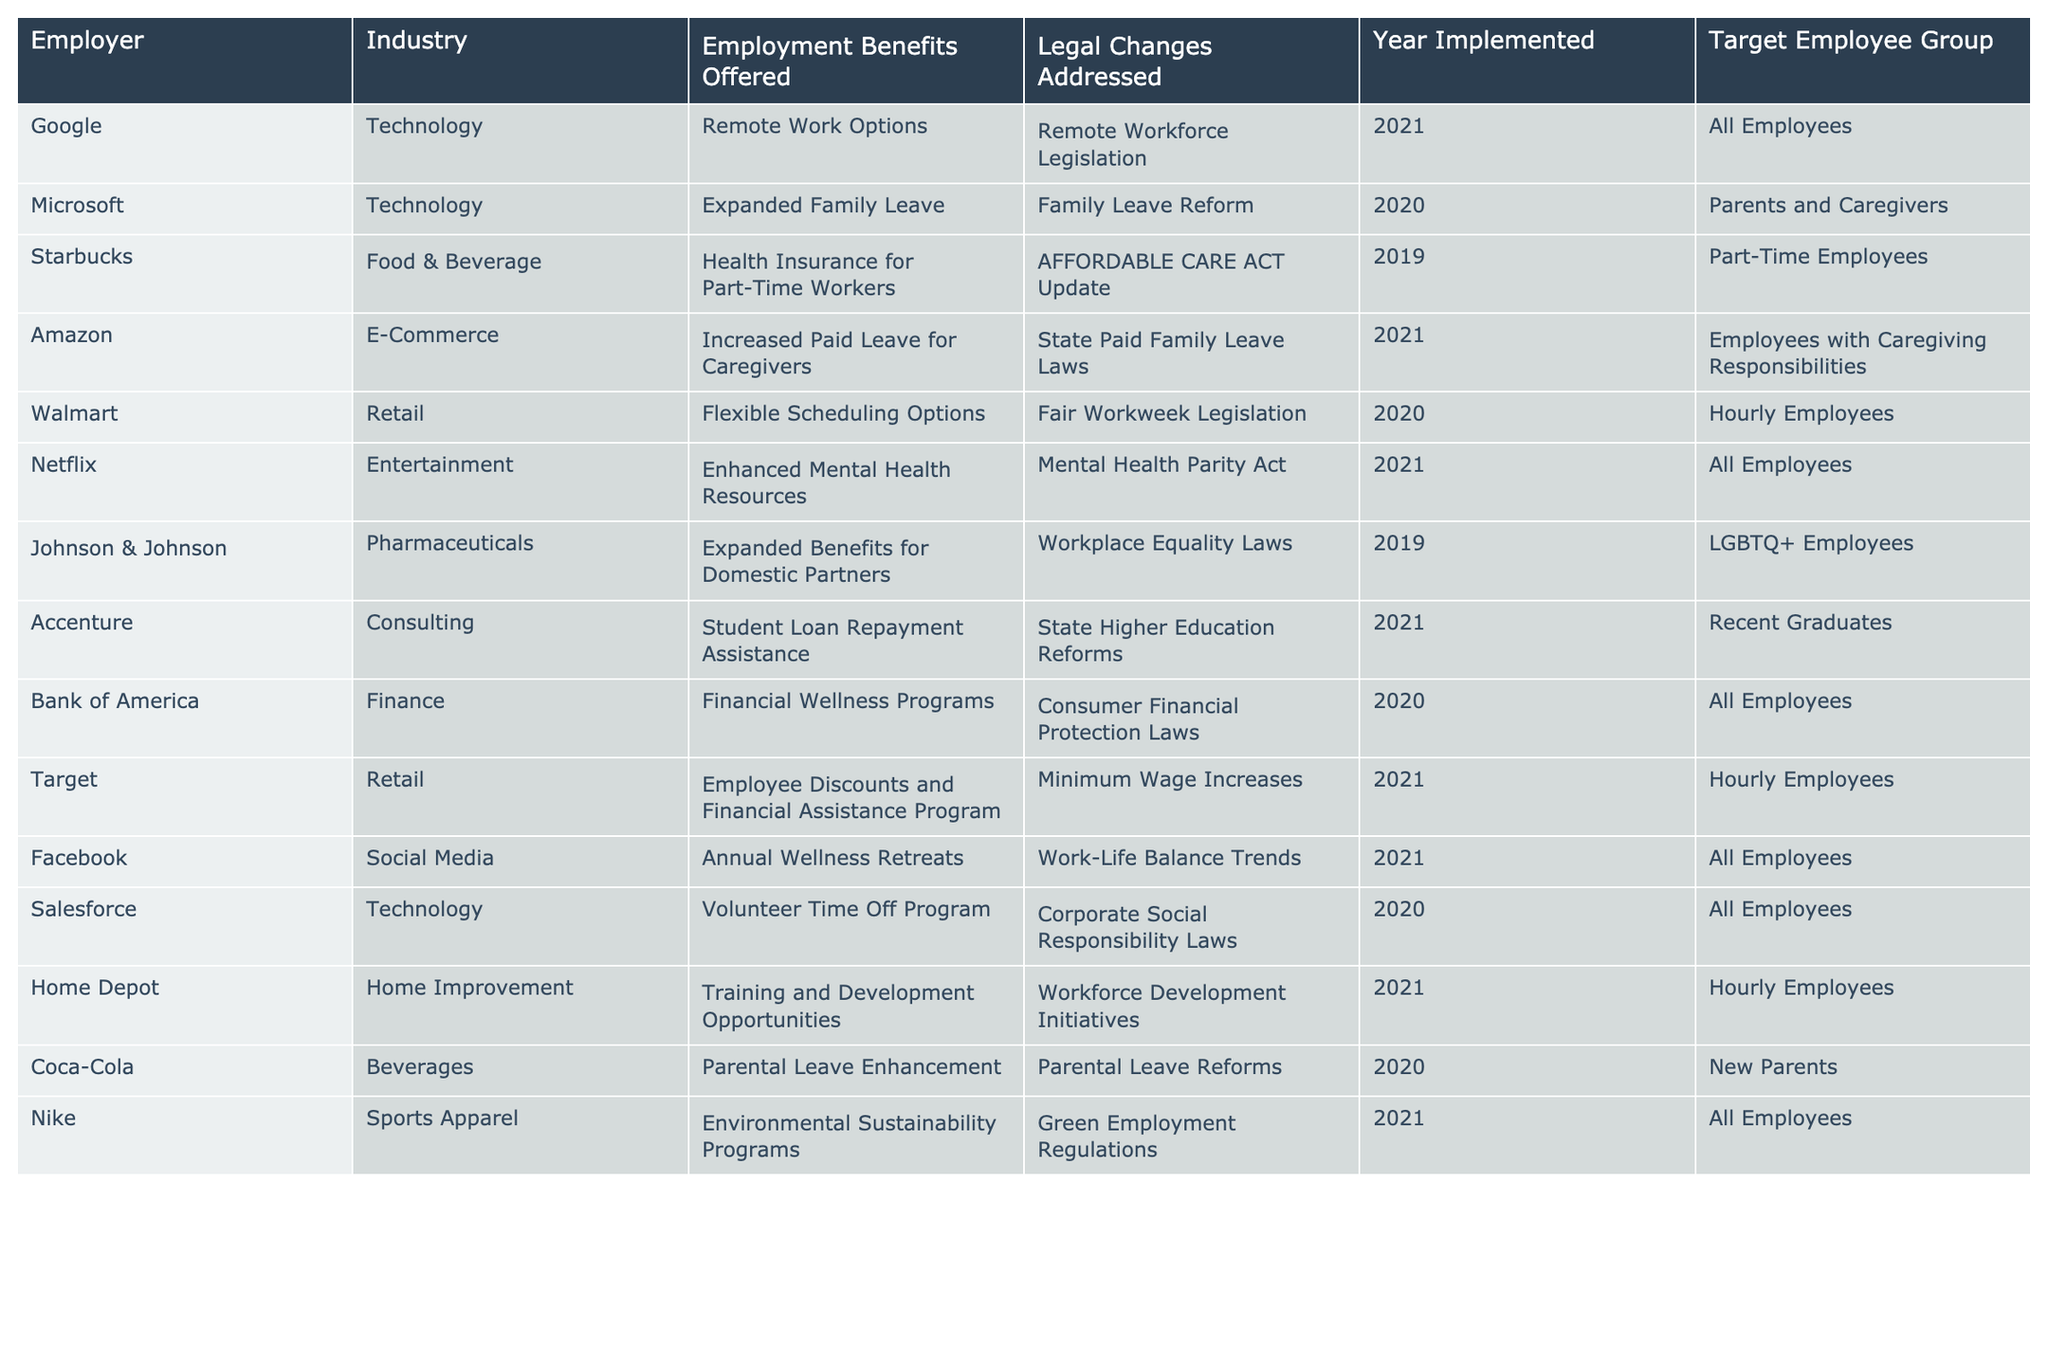What employment benefit did Walmart offer in response to legal changes? The table lists Walmart's employment benefit as Flexible Scheduling Options. This is specifically addressed under Fair Workweek Legislation.
Answer: Flexible Scheduling Options Which industry offers expanded family leave in the table? Looking at the table, Microsoft in the Technology industry offers Expanded Family Leave, which addresses Family Leave Reform.
Answer: Technology How many employers implemented benefits related to legal changes in 2021? By counting the entries under the Year Implemented column for 2021, we find five employers: Google, Amazon, Netflix, Facebook, and Nike.
Answer: 5 Did Johnson & Johnson offer benefits for employees not in the LGBTQ+ group? Checking the Target Employee Group, Johnson & Johnson specifically addresses LGBTQ+ Employees, indicating that the offered benefits are not targeted at employees outside this group.
Answer: No Which employers offered benefits related to caregiving? The table shows two employers, Amazon and Microsoft, which provided benefits addressing caregiving responsibilities and family leave, respectively.
Answer: Amazon, Microsoft What is the common legal change addressed by the majority of employers listed? By reviewing the Legal Changes Addressed column, the most frequent legal change seems to be related to increased family or parental leave, as it appears multiple times across Starbucks, Coca-Cola, and Amazon.
Answer: Increased family or parental leave For which type of employees did Accenture implement student loan repayment assistance? According to the Target Employee Group for Accenture, the benefit is specifically targeted at Recent Graduates.
Answer: Recent Graduates Do all employees at Netflix benefit from the new mental health resources? The table indicates that the Enhanced Mental Health Resources benefit provided by Netflix is available to All Employees, confirming that indeed every employee benefits from it.
Answer: Yes How many employers provided benefits specifically for hourly employees? Upon counting the entries in the Target Employee Group for Hourly Employees, we find there are three employers: Walmart, Target, and Home Depot.
Answer: 3 Which employer has introduced environmental sustainability programs and in what year? According to the Employer column, Nike has introduced Environmental Sustainability Programs, and the implementation year is 2021.
Answer: Nike, 2021 